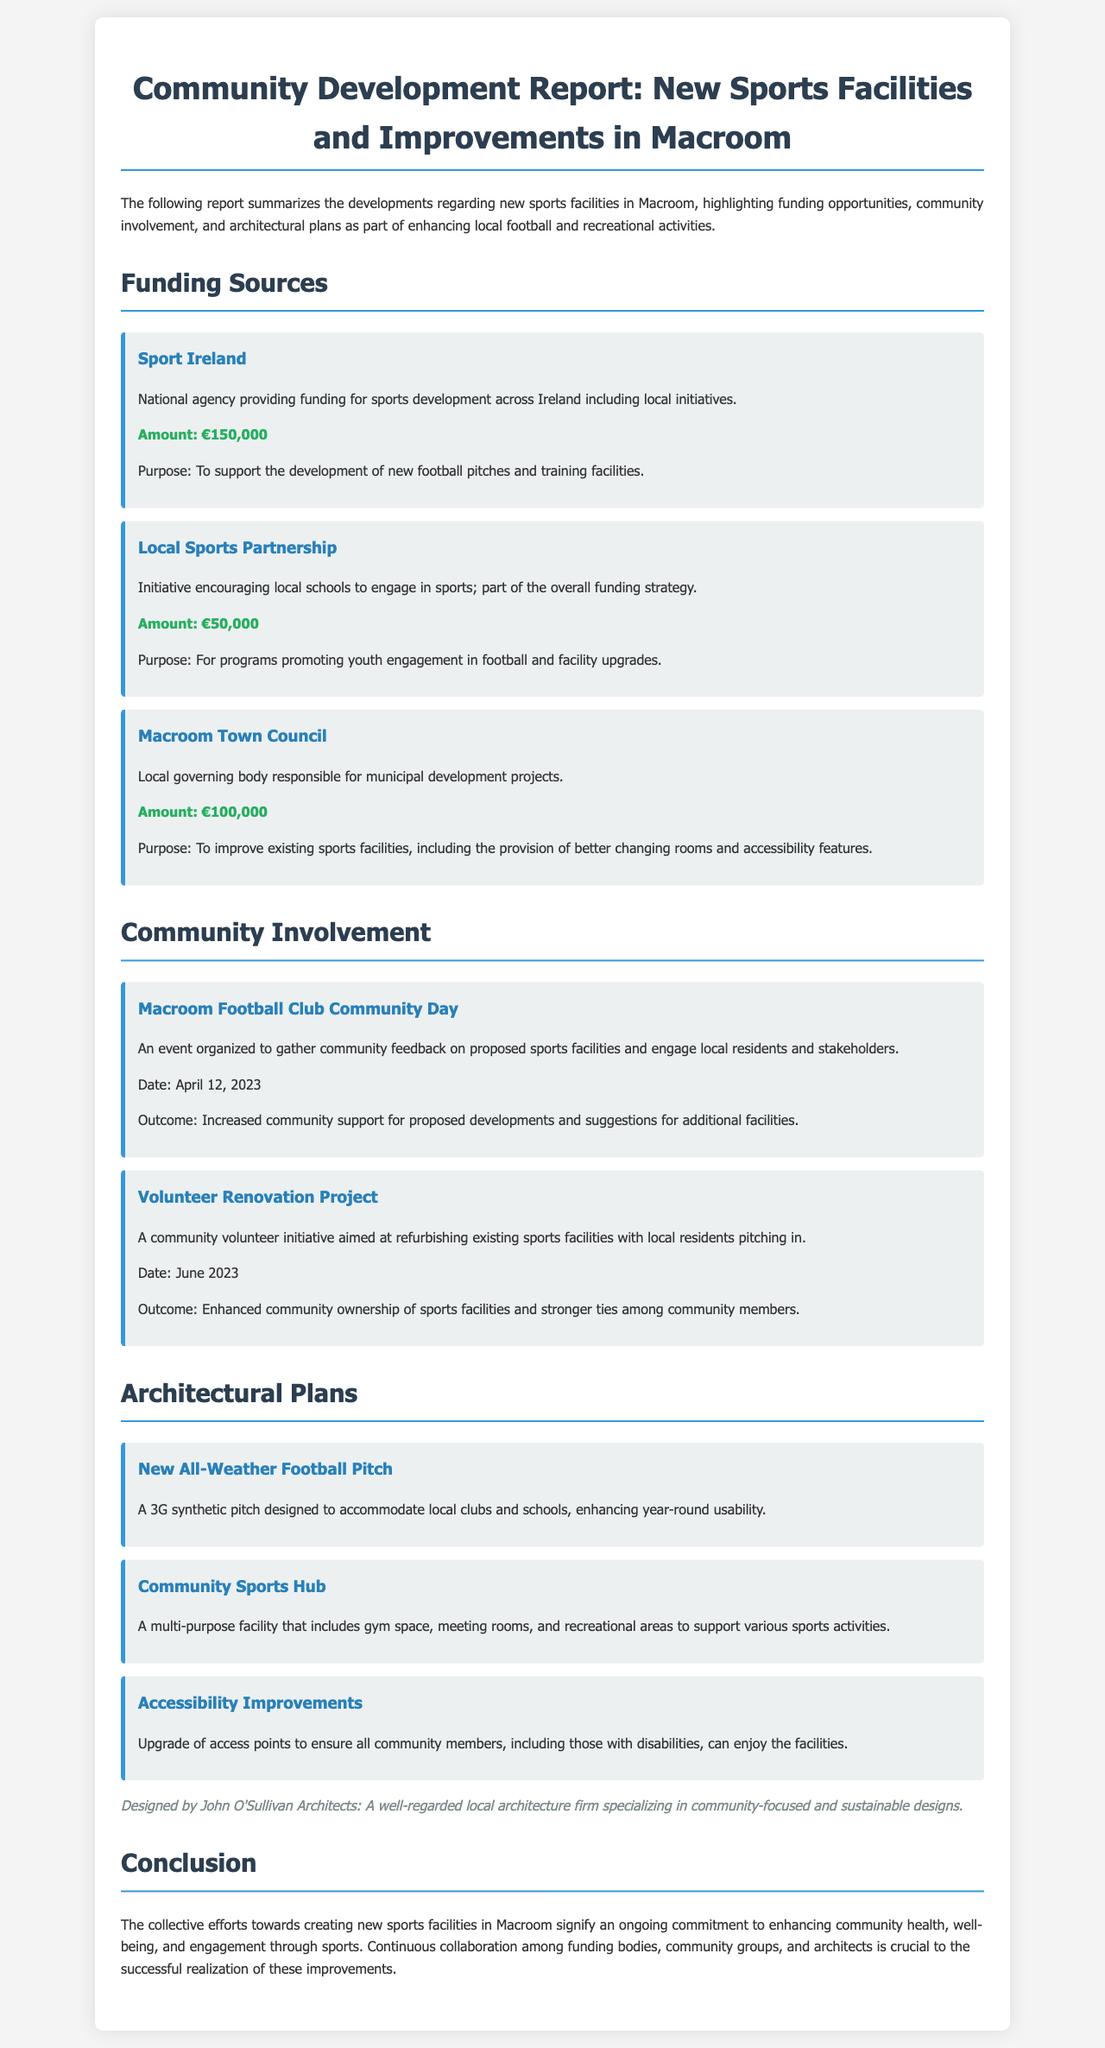What is the total funding from Sport Ireland? The document states that Sport Ireland provides €150,000 for sports development.
Answer: €150,000 When was the Macroom Football Club Community Day held? The document mentions that the event took place on April 12, 2023.
Answer: April 12, 2023 What is the purpose of the funding from the Local Sports Partnership? The purpose of the funding is to promote youth engagement in football and facility upgrades.
Answer: Promote youth engagement in football and facility upgrades Who designed the architectural plans for the new facilities? The document specifies that the plans were designed by John O'Sullivan Architects.
Answer: John O'Sullivan Architects How much funding was provided by Macroom Town Council? According to the document, Macroom Town Council provided €100,000 for improvements.
Answer: €100,000 What type of pitch is being constructed? The document states that a 3G synthetic pitch is being built.
Answer: 3G synthetic pitch What was an outcome of the Volunteer Renovation Project? The document indicates that it enhanced community ownership of sports facilities.
Answer: Enhanced community ownership of sports facilities What facility is planned to include gym space and recreational areas? The Community Sports Hub is planned to include gym space and recreational areas.
Answer: Community Sports Hub 